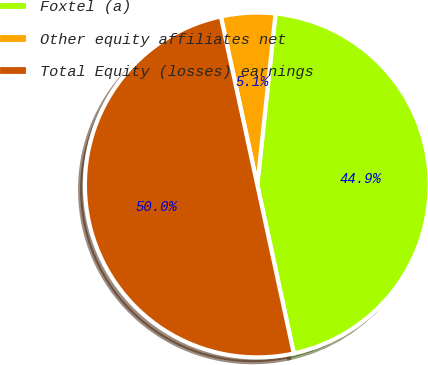Convert chart to OTSL. <chart><loc_0><loc_0><loc_500><loc_500><pie_chart><fcel>Foxtel (a)<fcel>Other equity affiliates net<fcel>Total Equity (losses) earnings<nl><fcel>44.92%<fcel>5.08%<fcel>50.0%<nl></chart> 